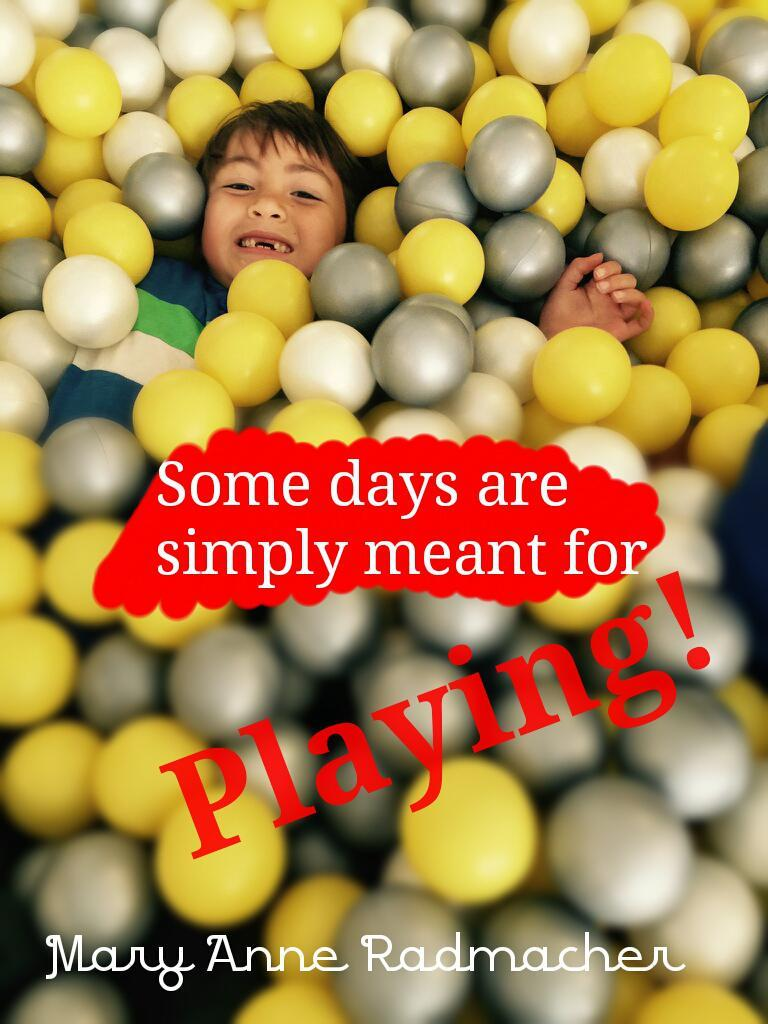Who is the main subject in the image? There is a boy in the image. What is the boy wearing? The boy is wearing a dress. What else can be seen around the boy? There is a group of balls around the boy. Is there any text visible in the image? Yes, there is some text visible in the foreground of the image. What type of seed is the boy planting in the image? There is no seed or planting activity depicted in the image; the boy is surrounded by a group of balls. 